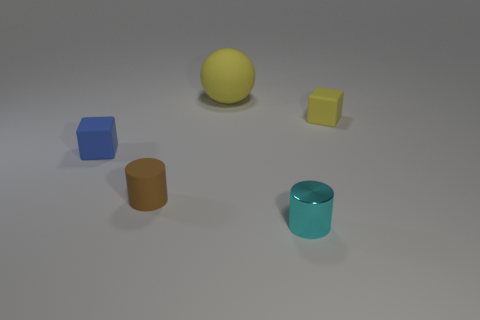Is the number of tiny blue objects less than the number of tiny matte things?
Keep it short and to the point. Yes. The yellow object that is to the right of the small metal cylinder that is in front of the large ball behind the brown matte cylinder is what shape?
Provide a short and direct response. Cube. There is another object that is the same color as the large matte object; what is its shape?
Give a very brief answer. Cube. Are there any rubber things?
Keep it short and to the point. Yes. Does the cyan object have the same size as the yellow rubber ball that is to the left of the cyan metal cylinder?
Make the answer very short. No. Are there any small cyan objects on the right side of the cube that is in front of the tiny yellow rubber object?
Keep it short and to the point. Yes. The tiny object that is both on the right side of the yellow rubber ball and in front of the small blue matte cube is made of what material?
Your answer should be very brief. Metal. There is a tiny block that is in front of the rubber cube behind the small matte cube that is to the left of the shiny cylinder; what color is it?
Your answer should be very brief. Blue. What color is the rubber cylinder that is the same size as the blue rubber block?
Your answer should be compact. Brown. There is a rubber sphere; is it the same color as the small rubber block that is right of the shiny cylinder?
Keep it short and to the point. Yes. 